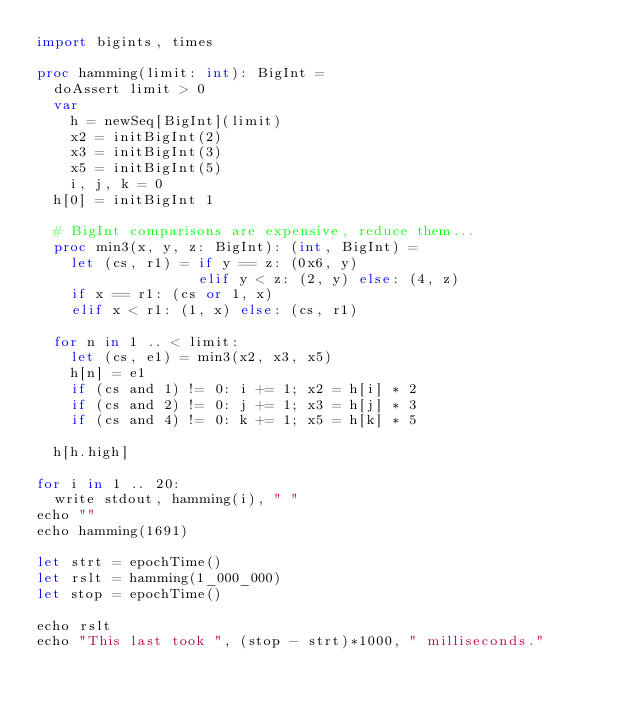<code> <loc_0><loc_0><loc_500><loc_500><_Nim_>import bigints, times

proc hamming(limit: int): BigInt =
  doAssert limit > 0
  var
    h = newSeq[BigInt](limit)
    x2 = initBigInt(2)
    x3 = initBigInt(3)
    x5 = initBigInt(5)
    i, j, k = 0
  h[0] = initBigInt 1

  # BigInt comparisons are expensive, reduce them...
  proc min3(x, y, z: BigInt): (int, BigInt) =
    let (cs, r1) = if y == z: (0x6, y)
                   elif y < z: (2, y) else: (4, z)
    if x == r1: (cs or 1, x)
    elif x < r1: (1, x) else: (cs, r1)

  for n in 1 .. < limit:
    let (cs, e1) = min3(x2, x3, x5)
    h[n] = e1
    if (cs and 1) != 0: i += 1; x2 = h[i] * 2
    if (cs and 2) != 0: j += 1; x3 = h[j] * 3
    if (cs and 4) != 0: k += 1; x5 = h[k] * 5

  h[h.high]

for i in 1 .. 20:
  write stdout, hamming(i), " "
echo ""
echo hamming(1691)

let strt = epochTime()
let rslt = hamming(1_000_000)
let stop = epochTime()

echo rslt
echo "This last took ", (stop - strt)*1000, " milliseconds."
</code> 